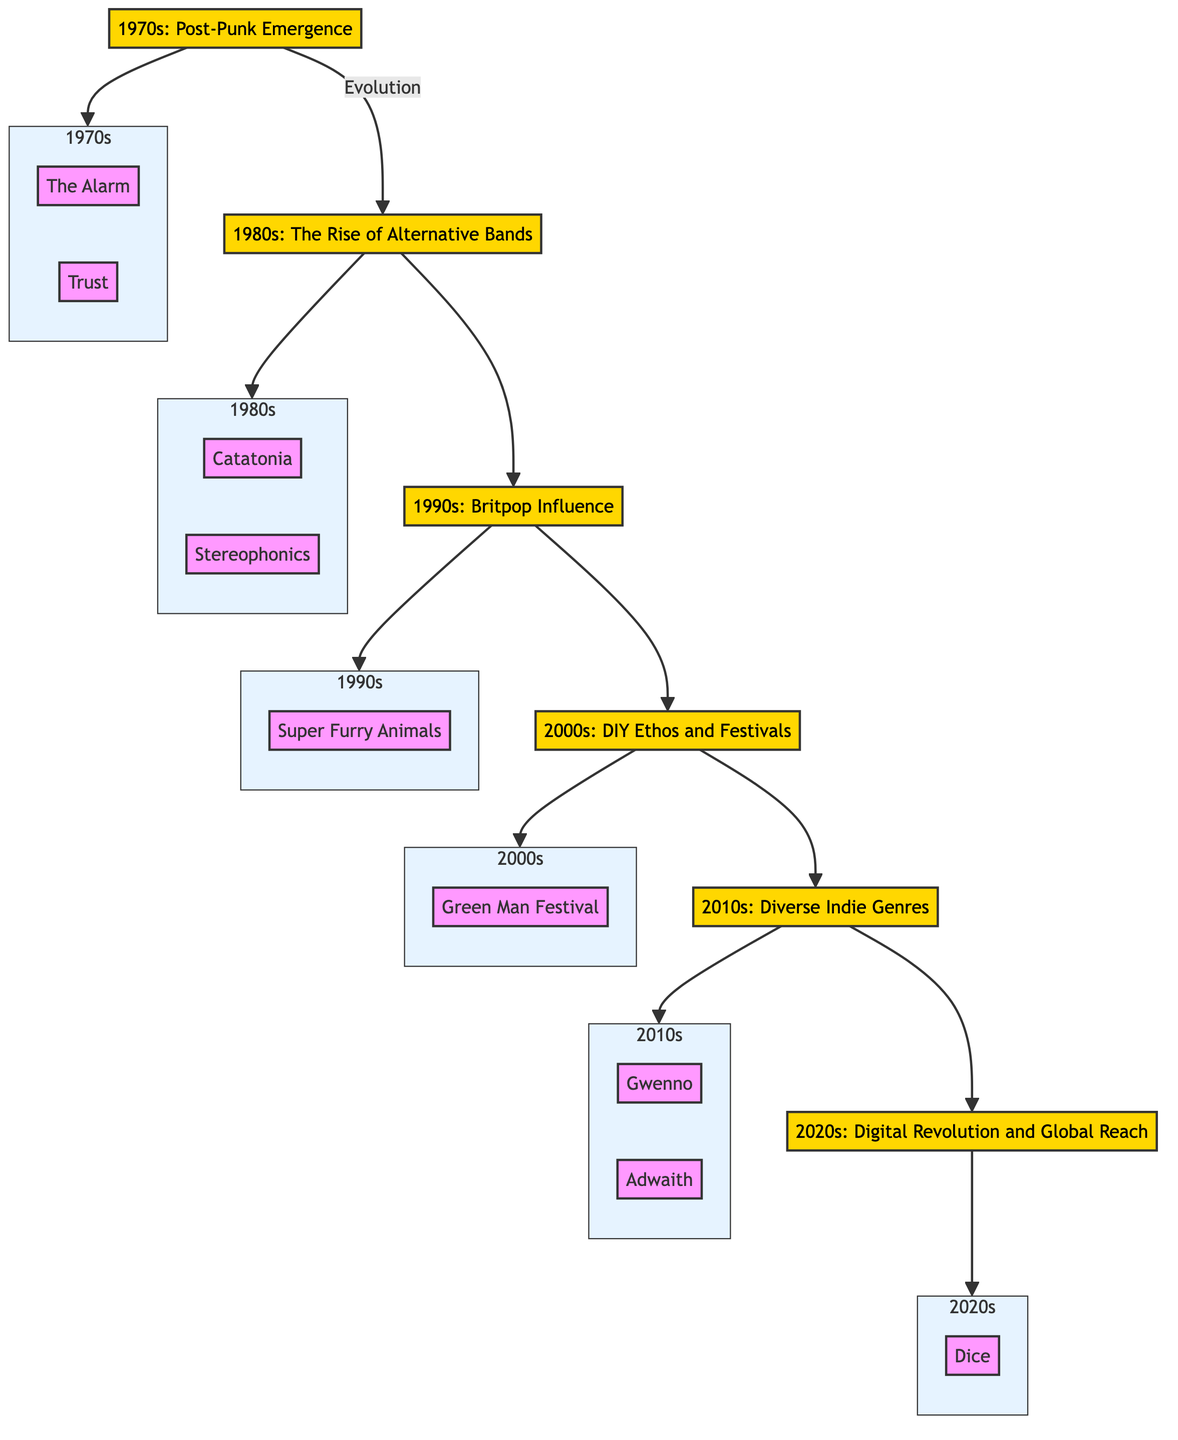What does the 1970s represent in the diagram? The diagram labels the 1970s as "Post-Punk Emergence," indicating that it marks the beginning of the indie scene in Wales with bands like The Alarm and Trust.
Answer: Post-Punk Emergence How many major decades are represented in the flow chart? The flow chart outlines six decades: 1970s, 1980s, 1990s, 2000s, 2010s, and 2020s, each representing a different phase in the evolution of indie music in Wales.
Answer: Six Which bands are associated with the 1980s in the diagram? The 1980s in the diagram is connected to Welsh bands such as Catatonia and Stereophonics, highlighting their role in developing a distinct indie sound during this decade.
Answer: Catatonia, Stereophonics What genre influence is noted in the 1990s? The 1990s section of the flow chart mentions the "Britpop Influence," indicating that Welsh bands like Super Furry Animals contributed to and gained popularity within the broader Britpop movement.
Answer: Britpop Influence Which decade saw the emergence of diverse indie genres? The diagram indicates that the 2010s was characterized by the "Diverse Indie Genres," showing a significant variety in musical styles emerging from Welsh artists during this period.
Answer: 2010s What festival is highlighted in the 2000s? In the 2000s, the flow chart specifically mentions the "Green Man Festival," which illustrates the rise of grassroots music events that showcase indie talent from Wales.
Answer: Green Man Festival Which Welsh artist is associated with the 2010s? The 2010s section identifies artists like Gwenno and Adwaith as key figures representing the varied indie genres that emerged during this decade in Wales.
Answer: Gwenno What is the main theme of the 2020s in the diagram? The 2020s is described as the "Digital Revolution and Global Reach," emphasizing how Welsh indie artists utilize streaming platforms to connect with global audiences and expand their reach.
Answer: Digital Revolution and Global Reach Which direction do the arrows in the flow chart indicate? The arrows in the diagram lead from one decade to the next, suggesting a chronological evolution and continuity of the indie music scene in Wales across the decades.
Answer: Chronological evolution 